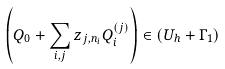Convert formula to latex. <formula><loc_0><loc_0><loc_500><loc_500>\left ( Q _ { 0 } + \sum _ { i , j } z _ { j , n _ { i } } Q ^ { ( j ) } _ { i } \right ) \in \left ( U _ { h } + \Gamma _ { 1 } \right )</formula> 